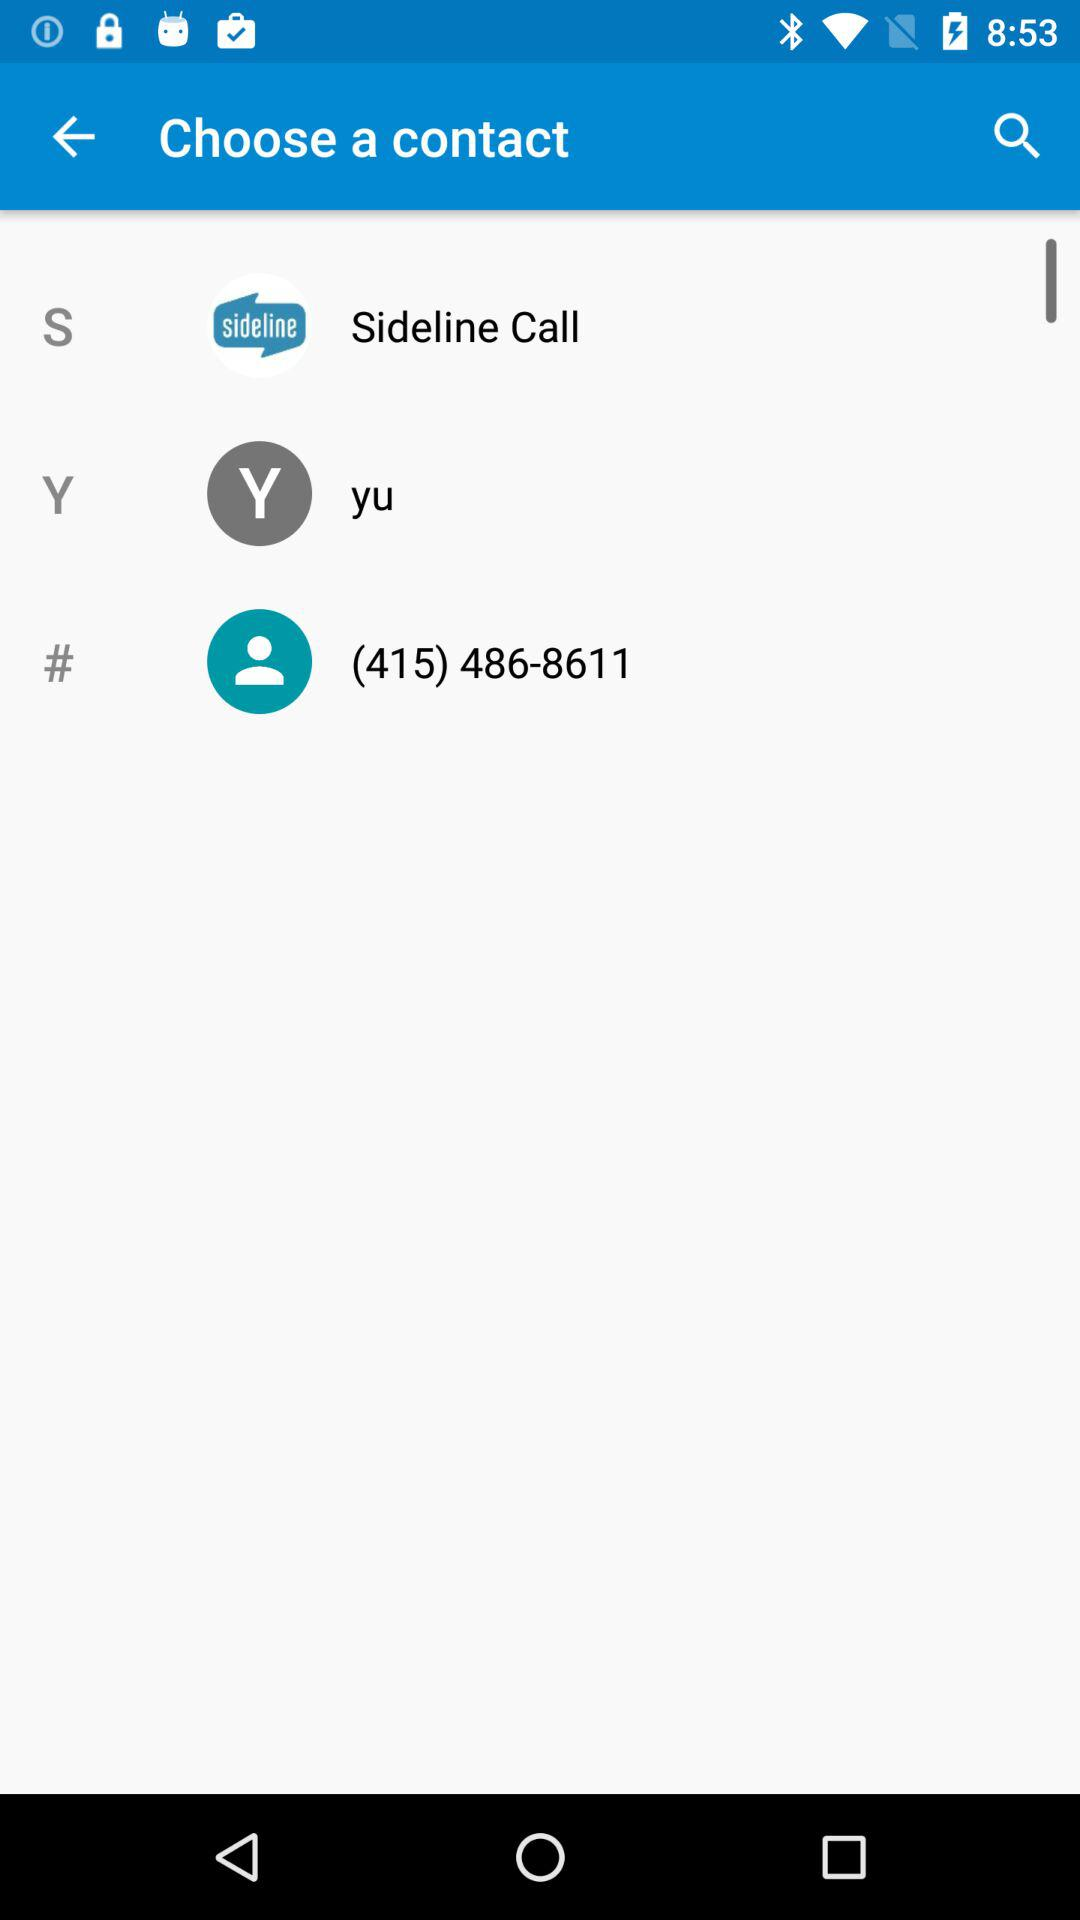What's the country code?
When the provided information is insufficient, respond with <no answer>. <no answer> 